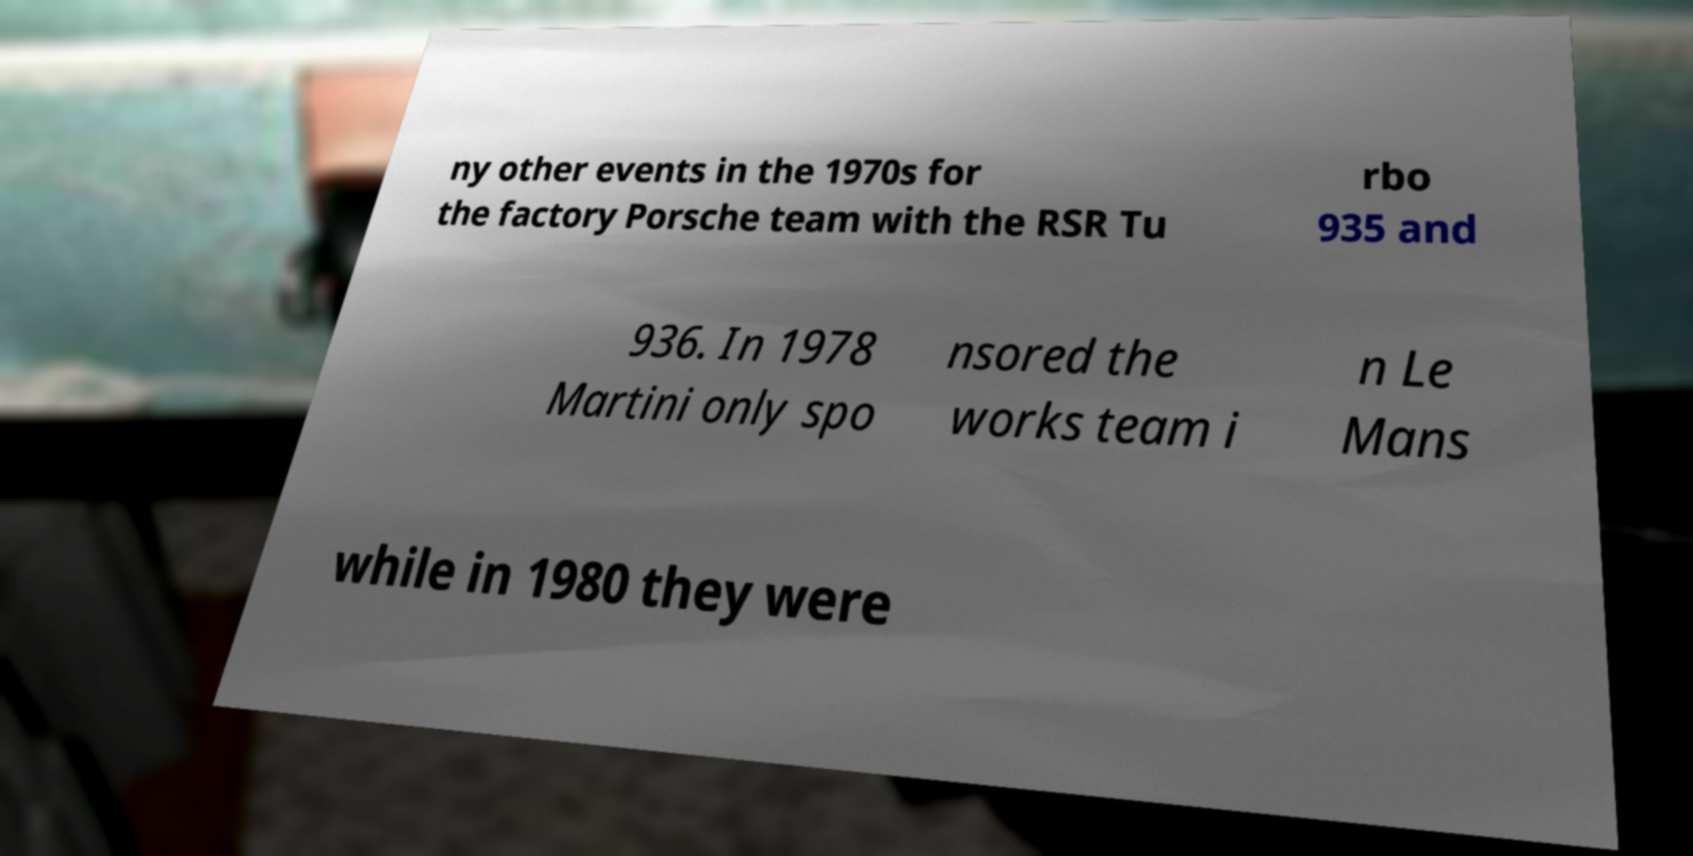Can you accurately transcribe the text from the provided image for me? ny other events in the 1970s for the factory Porsche team with the RSR Tu rbo 935 and 936. In 1978 Martini only spo nsored the works team i n Le Mans while in 1980 they were 